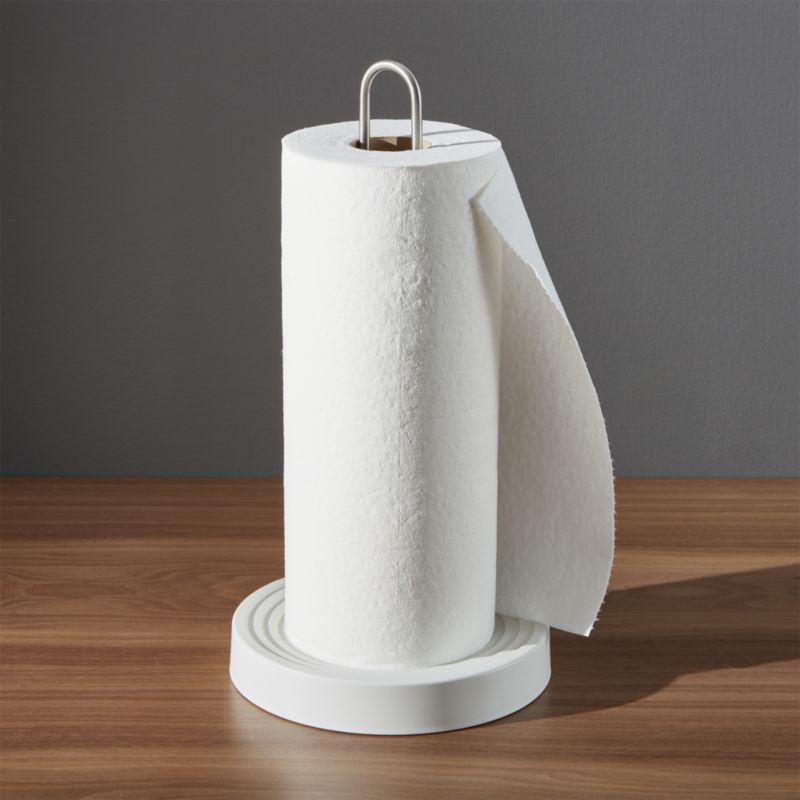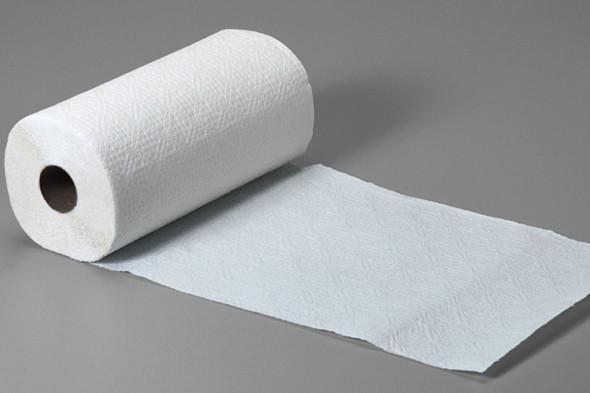The first image is the image on the left, the second image is the image on the right. For the images shown, is this caption "The left image contains a paper towel stand." true? Answer yes or no. Yes. 